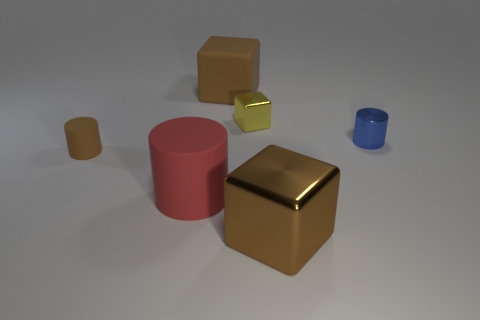How many objects are there in total, and can you classify them by color? In the image, I can identify five distinct objects. Each object has its own unique color: there is one pink cylinder, one gold cube, one small blue cylinder, and two square items that seem to be a shade of yellow or possibly light green. The pink and blue objects are solid colors with no variations, while the yellow squares have a slight gradient, possibly due to lighting conditions. 